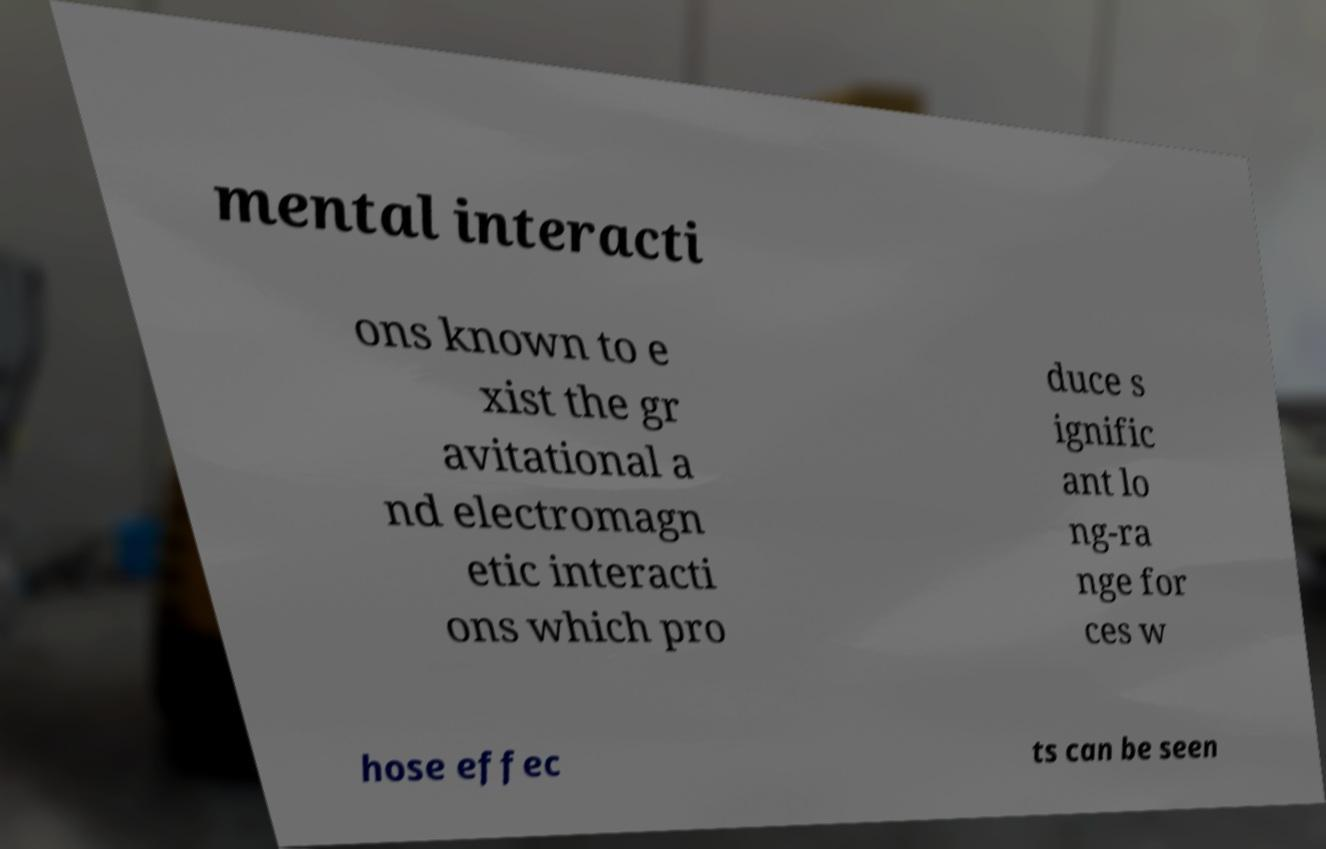Can you accurately transcribe the text from the provided image for me? mental interacti ons known to e xist the gr avitational a nd electromagn etic interacti ons which pro duce s ignific ant lo ng-ra nge for ces w hose effec ts can be seen 